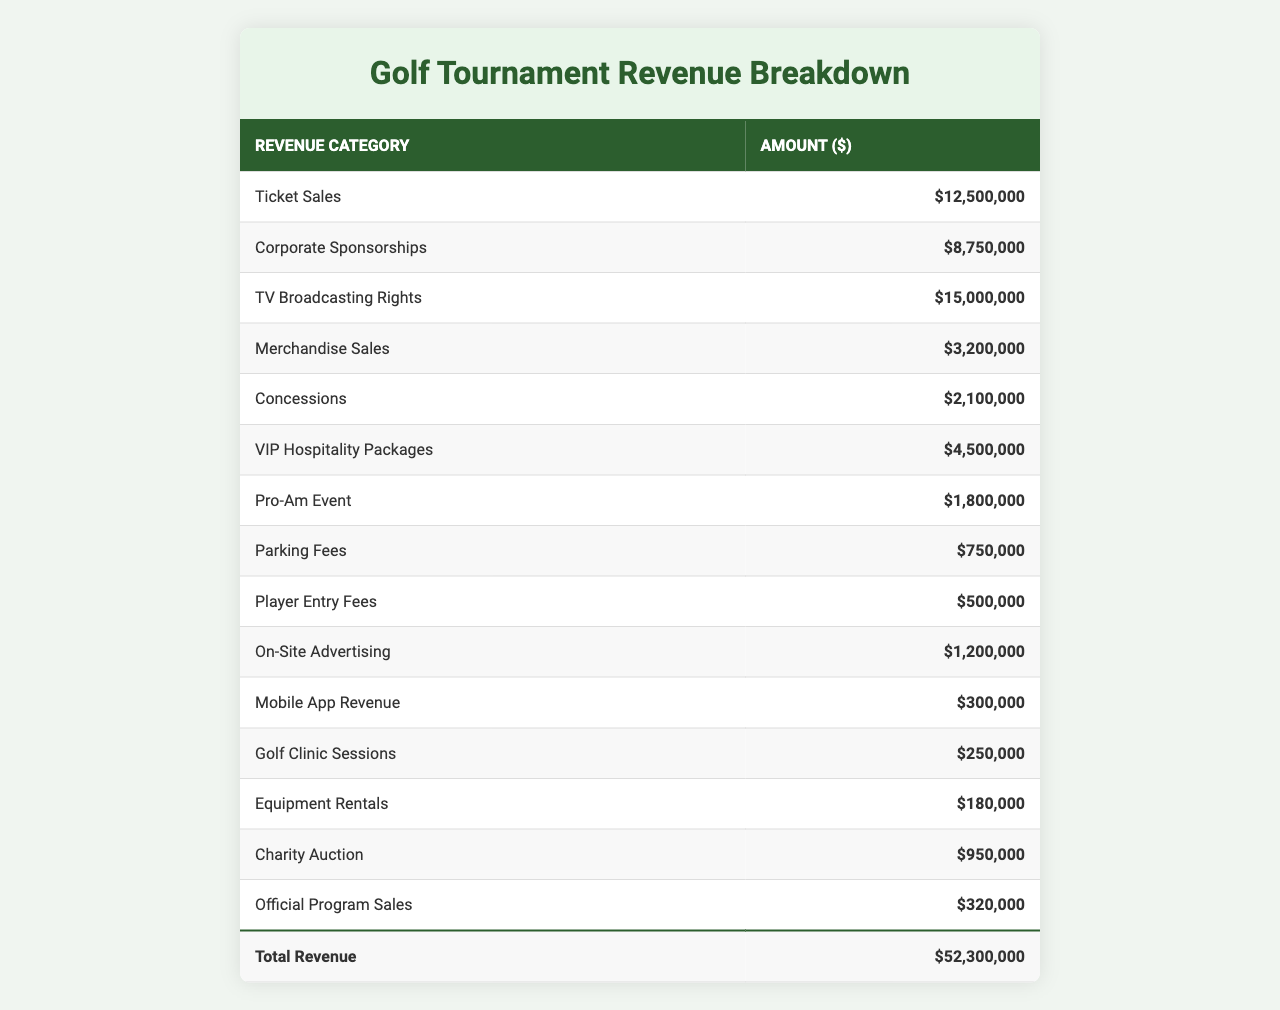What is the total revenue generated from ticket sales? The amount listed under ticket sales is $12,500,000, which is the total revenue generated from this category.
Answer: $12,500,000 What revenue category has the lowest amount? In the table, the category with the lowest revenue is "Equipment Rentals," which amounts to $180,000.
Answer: $180,000 How much more revenue is generated from TV broadcasting rights compared to merchandise sales? TV broadcasting rights generated $15,000,000, and merchandise sales generated $3,200,000. The difference is $15,000,000 - $3,200,000 = $11,800,000.
Answer: $11,800,000 What is the total revenue from concessions and parking fees combined? Concessions generate $2,100,000 and parking fees generate $750,000. When summed, $2,100,000 + $750,000 = $2,850,000.
Answer: $2,850,000 Is revenue from corporate sponsorships greater than the combined revenue from player entry fees and on-site advertising? Corporate sponsorships generate $8,750,000, while player entry fees ($500,000) and on-site advertising ($1,200,000) combined generate $1,700,000. Since $8,750,000 > $1,700,000, the statement is true.
Answer: Yes What percentage of the total revenue comes from VIP hospitality packages? The total revenue calculated is $44,080,000. VIP hospitality packages generate $4,500,000, so the percentage is ($4,500,000 / $44,080,000) * 100 = approximately 10.2%.
Answer: 10.2% Which two categories combined account for the highest revenue? The highest revenue categories are TV broadcasting rights ($15,000,000) and ticket sales ($12,500,000). Combined, they generate $15,000,000 + $12,500,000 = $27,500,000.
Answer: $27,500,000 What is the total revenue from merchandise sales, concessions, and charity auction? Merchandise sales are $3,200,000, concessions $2,100,000, and charity auction $950,000. Adding these amounts yields $3,200,000 + $2,100,000 + $950,000 = $6,250,000.
Answer: $6,250,000 Is the revenue from mobile app revenue greater than the revenue from pro-am events? Mobile app revenue is $300,000 and pro-am event revenue is $1,800,000. Since $300,000 < $1,800,000, this statement is false.
Answer: No What is the ratio of corporate sponsorships to ticket sales? Corporate sponsorship revenue is $8,750,000 and ticket sales revenue is $12,500,000. The ratio is $8,750,000 : $12,500,000, which simplifies to 7 : 10.
Answer: 7:10 